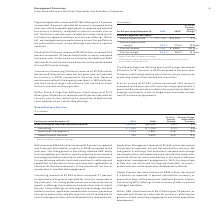According to International Business Machines's financial document, In 2019, which activity impacted the result? 2019 results were impacted by Red Hat purchase accounting and acquisition-related activity.. The document states: "** 2019 results were impacted by Red Hat purchase accounting and acquisition-related activity...." Also, What caused the gross profit margin decline in 2019? The gross profit margin decline was driven by the purchase price accounting impacts from the Red Hat acquisition.. The document states: "o 76.7 percent in 2019 compared to the prior year. The gross profit margin decline was driven by the purchase price accounting impacts from the Red Ha..." Also, What was the decrease in Pre-tax income in 2019? Pre-tax income of $7,952 million decreased 10.5 percent compared to the prior year with a pre-tax margin decline of 4.4 points to 30.6 percent which reflects the acquisition of Red Hat, ongoing investments in key strategic areas and lower income from IP partnership agreements.. The document states: "Pre-tax income of $7,952 million decreased 10.5 percent compared to the prior year with a pre-tax margin decline of 4.4 points to 30.6 percent which r..." Also, can you calculate: What was the average External gross profit in 2019 and 2018? To answer this question, I need to perform calculations using the financial data. The calculation is: (17,790 + 17,224) / 2, which equals 17507 (in millions). This is based on the information: "External gross profit $17,790 $17,224 3.3% External gross profit $17,790 $17,224 3.3%..." The key data points involved are: 17,224, 17,790. Also, can you calculate: What was the increase / (decrease) in the Pre-tax income from 2018 to 2019? Based on the calculation: 7,952 - 8,882, the result is -930 (in millions). This is based on the information: "Pre-tax income $ 7,952 $ 8,882 (10.5)% Pre-tax income $ 7,952 $ 8,882 (10.5)%..." The key data points involved are: 7,952, 8,882. Also, can you calculate: What was the average Pre tax margin in 2018 and 2019? To answer this question, I need to perform calculations using the financial data. The calculation is: (30.6% + 35.0%) / 2, which equals 32.8 (percentage). This is based on the information: "Pre-tax margin 30.6% 35.0% (4.4)pts. itive Applications revenue of $5,765 million grew 2.3 percent as reported (4 percent adjusted for currency) compared to the prior year, driven by doubl Pre-tax mar..." The key data points involved are: 30.6, 35.0. 